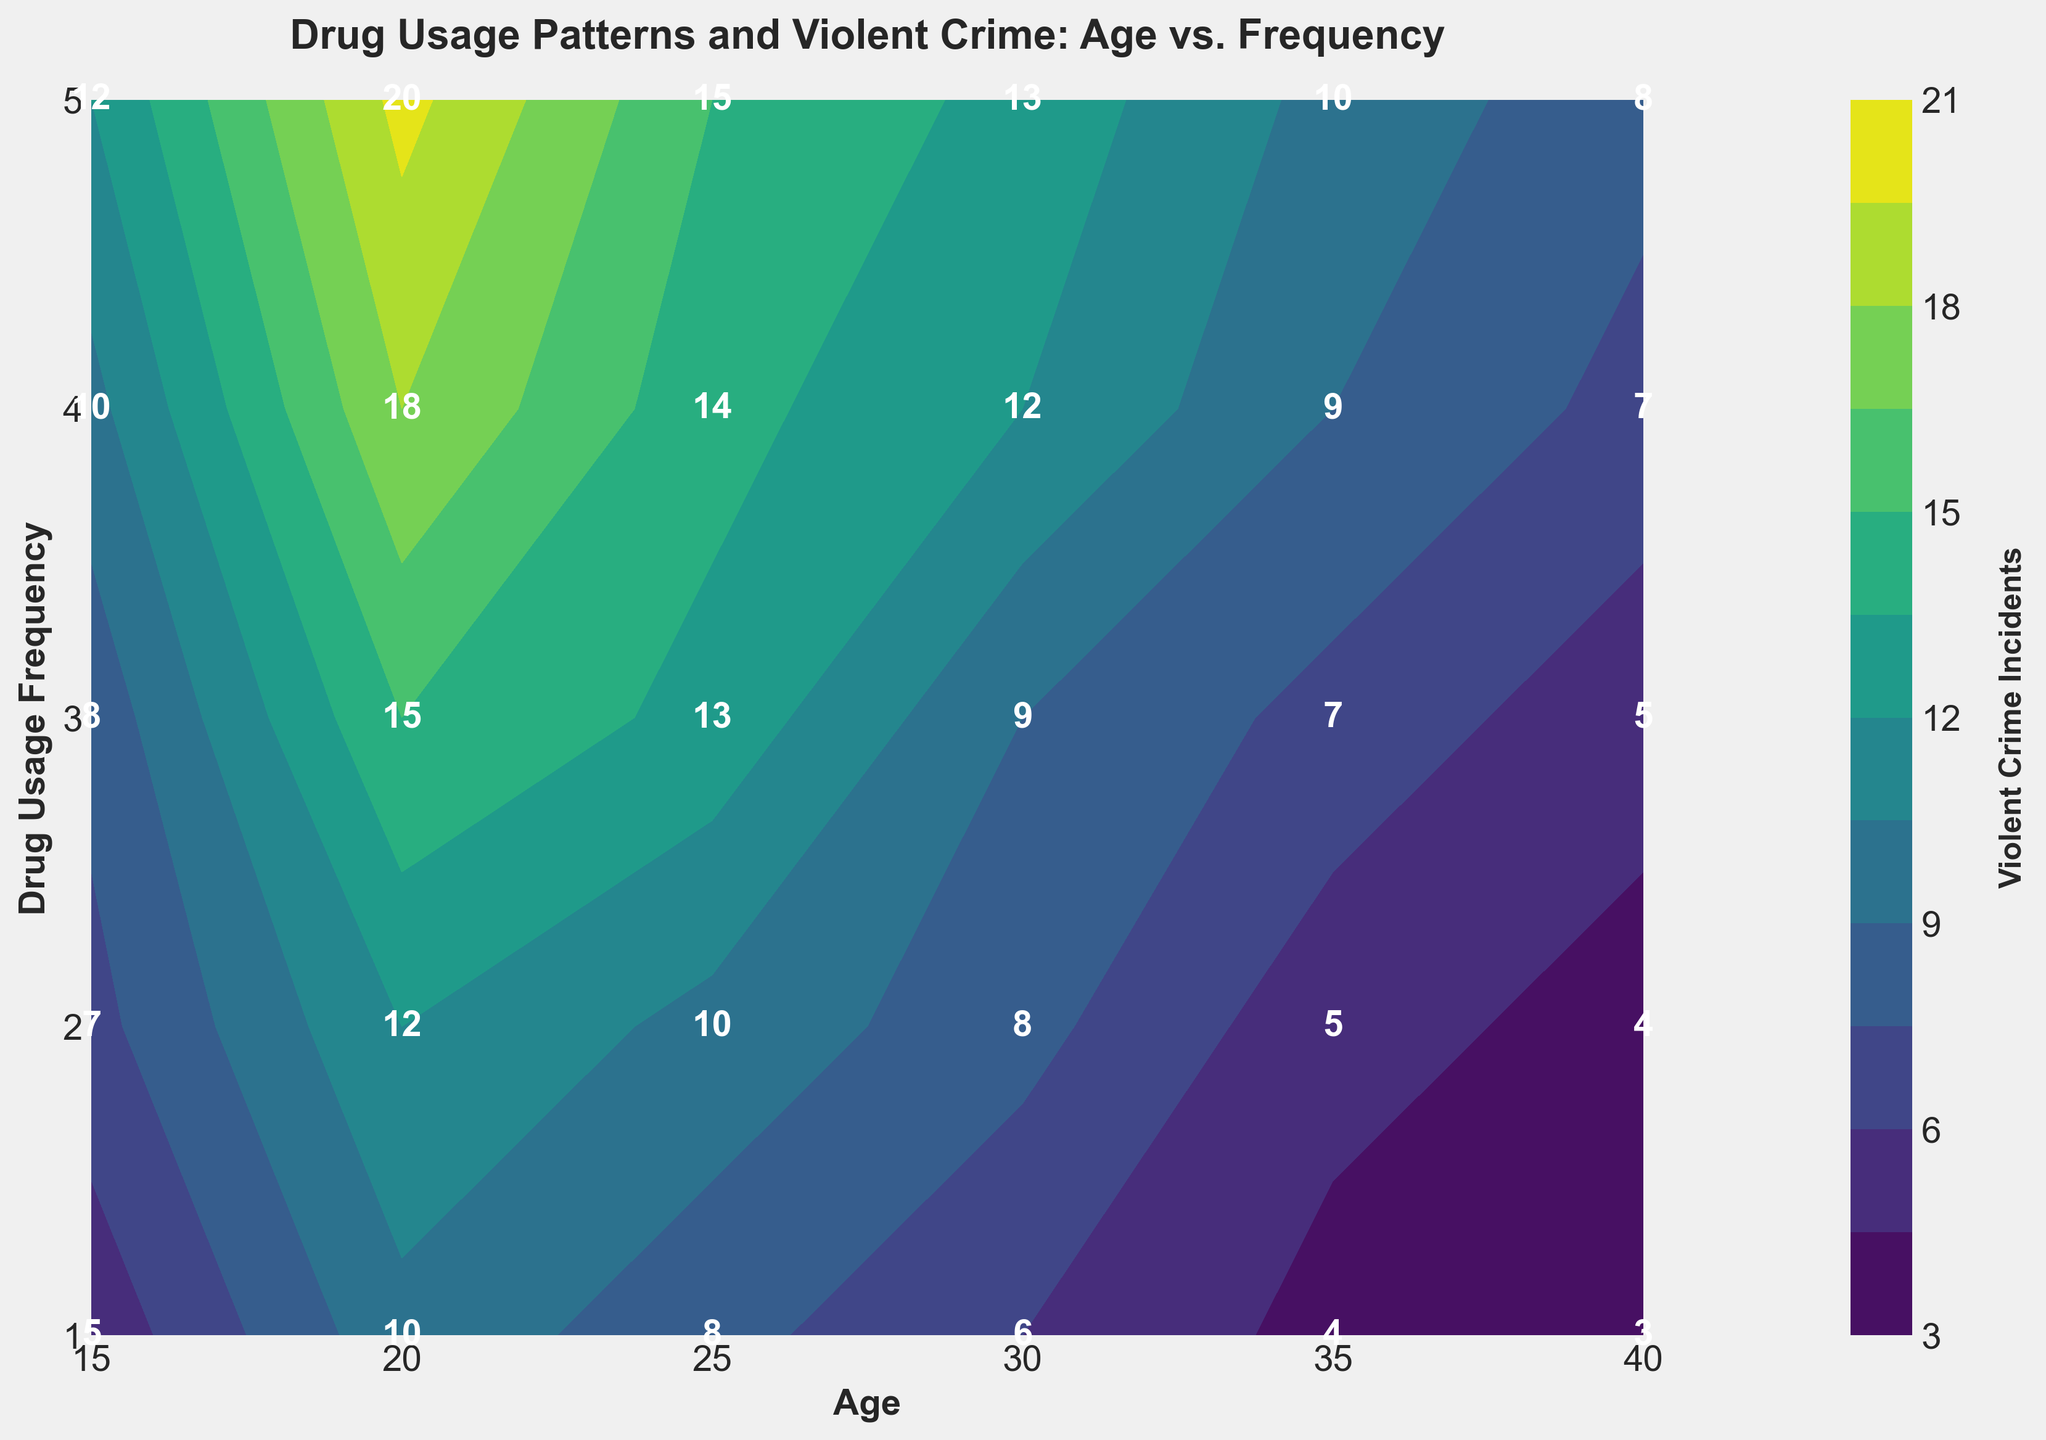What is the title of the figure? The title of the figure is placed at the top center and is written in a larger font than other text elements. The title is "Drug Usage Patterns and Violent Crime: Age vs. Frequency."
Answer: Drug Usage Patterns and Violent Crime: Age vs. Frequency What information is displayed on the x-axis? The x-axis represents "Age" and has specific age values marked as ticks, such as 15, 20, 25, 30, 35, and 40.
Answer: Age What does the color gradient in the figure represent? The figure uses a color gradient to represent the 'Violent Crime Incidents.' The color bar on the side indicates that darker colors represent higher incidents, while lighter colors represent lower incidents.
Answer: Violent Crime Incidents At what age and drug usage frequency are the violent crime incidents the lowest? The lowest incidents can be found where the lightest color appears on the contour plot. The table shows the lightest color is at age 40 and drug usage frequency 1 with a value of 3.
Answer: Age 40, Drug Usage Frequency 1 What is the count of violent crime incidents for age 25 and drug usage frequency 4? Locate age 25 and drug usage frequency 4 on the contour plot and find the number inside the corresponding cell, which is 14.
Answer: 14 How does the number of violent crime incidents change from age 15 to age 40 for drug usage frequency 2? Starting from age 15, drug usage frequency 2 has violent crime incidents: 7, 12, 10, 8, 5, 4. Clearly, it decreases as age increases.
Answer: Decreases Which age group shows the highest violent crime incidents at drug usage frequency 3? In the contour plot, for drug usage frequency 3, the highest value is 15, which occurs at age 20.
Answer: Age 20 By how much does the number of violent crime incidents change from drug usage frequency 1 to 5 at age 30? At age 30, the violent crime incidents for usage frequency from 1 to 5 are: 6, 8, 9, 12, 13. The change is from 6 to 13, which is 13 - 6 = 7.
Answer: 7 What is the average number of violent crime incidents for drug usage frequency 4 among all age groups? Sum all the incidents for frequency 4 across ages (10, 18, 14, 12, 9, 7) and divide by the number of age groups (6). Calculation: (10+18+14+12+9+7) / 6 = 70 / 6 ≈ 11.67.
Answer: 11.67 What age and drug usage frequency combination has the highest number of violent crime incidents? In the contour plot, the highest number is found by locating the darkest color and checking the value. The highest number is 20 at age 20 and drug usage frequency 5.
Answer: Age 20, Drug Usage Frequency 5 